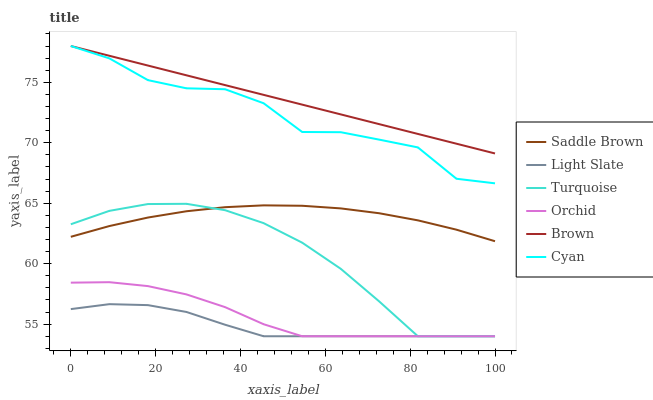Does Light Slate have the minimum area under the curve?
Answer yes or no. Yes. Does Brown have the maximum area under the curve?
Answer yes or no. Yes. Does Turquoise have the minimum area under the curve?
Answer yes or no. No. Does Turquoise have the maximum area under the curve?
Answer yes or no. No. Is Brown the smoothest?
Answer yes or no. Yes. Is Cyan the roughest?
Answer yes or no. Yes. Is Turquoise the smoothest?
Answer yes or no. No. Is Turquoise the roughest?
Answer yes or no. No. Does Turquoise have the lowest value?
Answer yes or no. Yes. Does Cyan have the lowest value?
Answer yes or no. No. Does Cyan have the highest value?
Answer yes or no. Yes. Does Turquoise have the highest value?
Answer yes or no. No. Is Saddle Brown less than Brown?
Answer yes or no. Yes. Is Saddle Brown greater than Orchid?
Answer yes or no. Yes. Does Brown intersect Cyan?
Answer yes or no. Yes. Is Brown less than Cyan?
Answer yes or no. No. Is Brown greater than Cyan?
Answer yes or no. No. Does Saddle Brown intersect Brown?
Answer yes or no. No. 